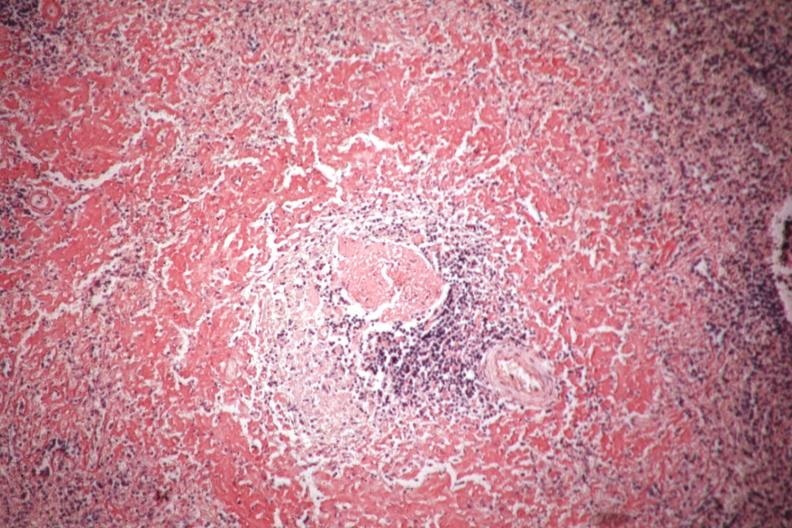what shown perifollicular amyloid?
Answer the question using a single word or phrase. Congo red 